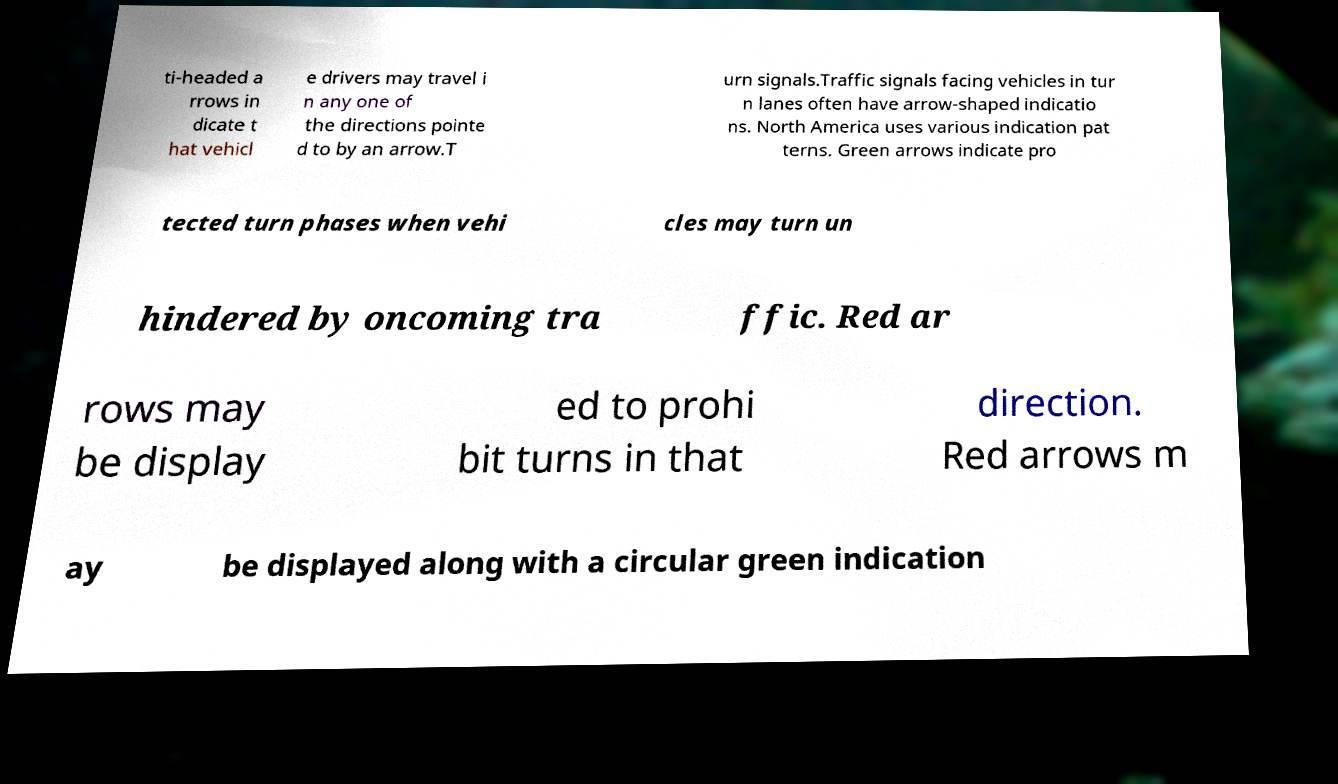What messages or text are displayed in this image? I need them in a readable, typed format. ti-headed a rrows in dicate t hat vehicl e drivers may travel i n any one of the directions pointe d to by an arrow.T urn signals.Traffic signals facing vehicles in tur n lanes often have arrow-shaped indicatio ns. North America uses various indication pat terns. Green arrows indicate pro tected turn phases when vehi cles may turn un hindered by oncoming tra ffic. Red ar rows may be display ed to prohi bit turns in that direction. Red arrows m ay be displayed along with a circular green indication 